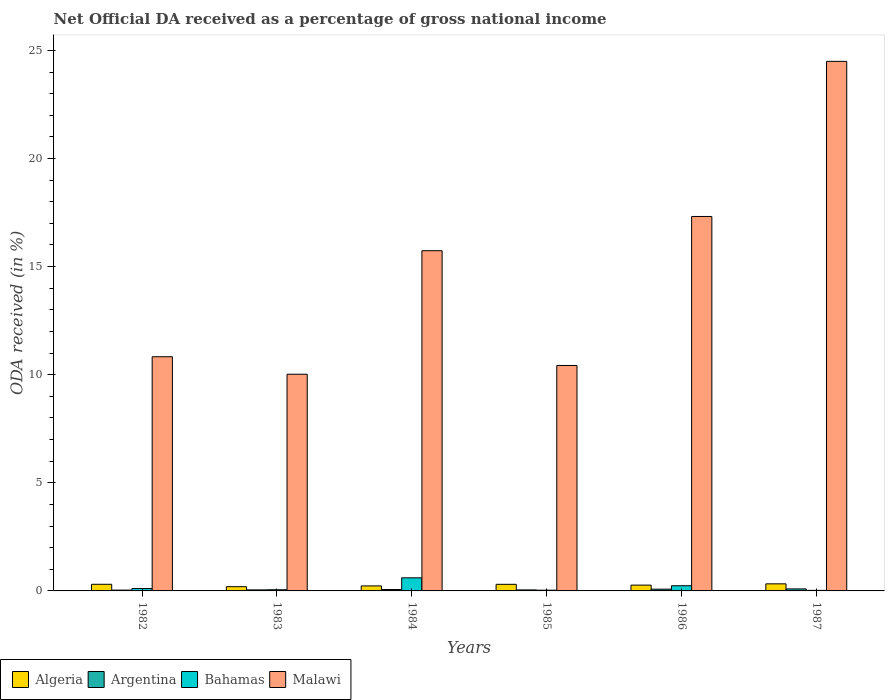How many groups of bars are there?
Offer a terse response. 6. Are the number of bars per tick equal to the number of legend labels?
Make the answer very short. Yes. Are the number of bars on each tick of the X-axis equal?
Offer a terse response. Yes. In how many cases, is the number of bars for a given year not equal to the number of legend labels?
Offer a very short reply. 0. What is the net official DA received in Bahamas in 1982?
Offer a very short reply. 0.11. Across all years, what is the maximum net official DA received in Malawi?
Provide a succinct answer. 24.49. Across all years, what is the minimum net official DA received in Algeria?
Keep it short and to the point. 0.2. In which year was the net official DA received in Argentina minimum?
Your response must be concise. 1982. What is the total net official DA received in Algeria in the graph?
Offer a very short reply. 1.64. What is the difference between the net official DA received in Bahamas in 1984 and that in 1987?
Keep it short and to the point. 0.58. What is the difference between the net official DA received in Bahamas in 1987 and the net official DA received in Algeria in 1984?
Ensure brevity in your answer.  -0.21. What is the average net official DA received in Argentina per year?
Offer a terse response. 0.06. In the year 1983, what is the difference between the net official DA received in Argentina and net official DA received in Malawi?
Give a very brief answer. -9.97. What is the ratio of the net official DA received in Argentina in 1986 to that in 1987?
Offer a terse response. 0.86. Is the net official DA received in Malawi in 1986 less than that in 1987?
Your response must be concise. Yes. Is the difference between the net official DA received in Argentina in 1983 and 1987 greater than the difference between the net official DA received in Malawi in 1983 and 1987?
Offer a terse response. Yes. What is the difference between the highest and the second highest net official DA received in Malawi?
Your answer should be compact. 7.18. What is the difference between the highest and the lowest net official DA received in Malawi?
Ensure brevity in your answer.  14.47. Is it the case that in every year, the sum of the net official DA received in Malawi and net official DA received in Bahamas is greater than the sum of net official DA received in Algeria and net official DA received in Argentina?
Offer a very short reply. No. Is it the case that in every year, the sum of the net official DA received in Malawi and net official DA received in Argentina is greater than the net official DA received in Bahamas?
Your response must be concise. Yes. How many bars are there?
Provide a succinct answer. 24. How many years are there in the graph?
Offer a terse response. 6. Are the values on the major ticks of Y-axis written in scientific E-notation?
Ensure brevity in your answer.  No. Does the graph contain grids?
Provide a succinct answer. No. Where does the legend appear in the graph?
Your answer should be very brief. Bottom left. How are the legend labels stacked?
Your response must be concise. Horizontal. What is the title of the graph?
Give a very brief answer. Net Official DA received as a percentage of gross national income. What is the label or title of the X-axis?
Provide a succinct answer. Years. What is the label or title of the Y-axis?
Your answer should be compact. ODA received (in %). What is the ODA received (in %) of Algeria in 1982?
Provide a succinct answer. 0.31. What is the ODA received (in %) in Argentina in 1982?
Make the answer very short. 0.04. What is the ODA received (in %) in Bahamas in 1982?
Give a very brief answer. 0.11. What is the ODA received (in %) of Malawi in 1982?
Offer a terse response. 10.83. What is the ODA received (in %) of Algeria in 1983?
Give a very brief answer. 0.2. What is the ODA received (in %) in Argentina in 1983?
Make the answer very short. 0.05. What is the ODA received (in %) in Bahamas in 1983?
Ensure brevity in your answer.  0.05. What is the ODA received (in %) in Malawi in 1983?
Ensure brevity in your answer.  10.02. What is the ODA received (in %) in Algeria in 1984?
Your answer should be very brief. 0.23. What is the ODA received (in %) in Argentina in 1984?
Provide a succinct answer. 0.06. What is the ODA received (in %) of Bahamas in 1984?
Offer a very short reply. 0.61. What is the ODA received (in %) in Malawi in 1984?
Provide a succinct answer. 15.74. What is the ODA received (in %) of Algeria in 1985?
Keep it short and to the point. 0.31. What is the ODA received (in %) in Argentina in 1985?
Your response must be concise. 0.05. What is the ODA received (in %) in Bahamas in 1985?
Make the answer very short. 0.03. What is the ODA received (in %) of Malawi in 1985?
Give a very brief answer. 10.43. What is the ODA received (in %) in Algeria in 1986?
Make the answer very short. 0.27. What is the ODA received (in %) in Argentina in 1986?
Offer a terse response. 0.08. What is the ODA received (in %) of Bahamas in 1986?
Provide a short and direct response. 0.24. What is the ODA received (in %) of Malawi in 1986?
Ensure brevity in your answer.  17.32. What is the ODA received (in %) in Algeria in 1987?
Give a very brief answer. 0.33. What is the ODA received (in %) of Argentina in 1987?
Keep it short and to the point. 0.09. What is the ODA received (in %) in Bahamas in 1987?
Give a very brief answer. 0.03. What is the ODA received (in %) in Malawi in 1987?
Offer a very short reply. 24.49. Across all years, what is the maximum ODA received (in %) of Algeria?
Your response must be concise. 0.33. Across all years, what is the maximum ODA received (in %) of Argentina?
Make the answer very short. 0.09. Across all years, what is the maximum ODA received (in %) in Bahamas?
Your answer should be very brief. 0.61. Across all years, what is the maximum ODA received (in %) of Malawi?
Offer a terse response. 24.49. Across all years, what is the minimum ODA received (in %) of Algeria?
Your response must be concise. 0.2. Across all years, what is the minimum ODA received (in %) in Argentina?
Make the answer very short. 0.04. Across all years, what is the minimum ODA received (in %) in Bahamas?
Your answer should be compact. 0.03. Across all years, what is the minimum ODA received (in %) in Malawi?
Keep it short and to the point. 10.02. What is the total ODA received (in %) of Algeria in the graph?
Ensure brevity in your answer.  1.64. What is the total ODA received (in %) in Argentina in the graph?
Keep it short and to the point. 0.37. What is the total ODA received (in %) in Bahamas in the graph?
Provide a short and direct response. 1.07. What is the total ODA received (in %) of Malawi in the graph?
Make the answer very short. 88.83. What is the difference between the ODA received (in %) of Algeria in 1982 and that in 1983?
Provide a short and direct response. 0.11. What is the difference between the ODA received (in %) of Argentina in 1982 and that in 1983?
Your answer should be compact. -0.01. What is the difference between the ODA received (in %) in Bahamas in 1982 and that in 1983?
Offer a very short reply. 0.06. What is the difference between the ODA received (in %) in Malawi in 1982 and that in 1983?
Offer a very short reply. 0.81. What is the difference between the ODA received (in %) in Algeria in 1982 and that in 1984?
Give a very brief answer. 0.08. What is the difference between the ODA received (in %) in Argentina in 1982 and that in 1984?
Give a very brief answer. -0.03. What is the difference between the ODA received (in %) of Bahamas in 1982 and that in 1984?
Your answer should be compact. -0.49. What is the difference between the ODA received (in %) of Malawi in 1982 and that in 1984?
Give a very brief answer. -4.9. What is the difference between the ODA received (in %) in Algeria in 1982 and that in 1985?
Give a very brief answer. 0. What is the difference between the ODA received (in %) of Argentina in 1982 and that in 1985?
Give a very brief answer. -0.01. What is the difference between the ODA received (in %) in Bahamas in 1982 and that in 1985?
Your response must be concise. 0.08. What is the difference between the ODA received (in %) of Malawi in 1982 and that in 1985?
Keep it short and to the point. 0.4. What is the difference between the ODA received (in %) in Algeria in 1982 and that in 1986?
Your answer should be very brief. 0.04. What is the difference between the ODA received (in %) in Argentina in 1982 and that in 1986?
Keep it short and to the point. -0.04. What is the difference between the ODA received (in %) in Bahamas in 1982 and that in 1986?
Provide a succinct answer. -0.13. What is the difference between the ODA received (in %) of Malawi in 1982 and that in 1986?
Provide a short and direct response. -6.49. What is the difference between the ODA received (in %) in Algeria in 1982 and that in 1987?
Give a very brief answer. -0.02. What is the difference between the ODA received (in %) of Argentina in 1982 and that in 1987?
Offer a terse response. -0.06. What is the difference between the ODA received (in %) in Bahamas in 1982 and that in 1987?
Your answer should be very brief. 0.09. What is the difference between the ODA received (in %) in Malawi in 1982 and that in 1987?
Keep it short and to the point. -13.66. What is the difference between the ODA received (in %) of Algeria in 1983 and that in 1984?
Keep it short and to the point. -0.04. What is the difference between the ODA received (in %) in Argentina in 1983 and that in 1984?
Your answer should be very brief. -0.02. What is the difference between the ODA received (in %) in Bahamas in 1983 and that in 1984?
Your answer should be compact. -0.55. What is the difference between the ODA received (in %) of Malawi in 1983 and that in 1984?
Offer a terse response. -5.71. What is the difference between the ODA received (in %) in Algeria in 1983 and that in 1985?
Offer a very short reply. -0.11. What is the difference between the ODA received (in %) of Argentina in 1983 and that in 1985?
Ensure brevity in your answer.  0. What is the difference between the ODA received (in %) in Bahamas in 1983 and that in 1985?
Provide a short and direct response. 0.02. What is the difference between the ODA received (in %) of Malawi in 1983 and that in 1985?
Give a very brief answer. -0.41. What is the difference between the ODA received (in %) in Algeria in 1983 and that in 1986?
Give a very brief answer. -0.07. What is the difference between the ODA received (in %) of Argentina in 1983 and that in 1986?
Make the answer very short. -0.03. What is the difference between the ODA received (in %) in Bahamas in 1983 and that in 1986?
Your answer should be compact. -0.19. What is the difference between the ODA received (in %) of Malawi in 1983 and that in 1986?
Ensure brevity in your answer.  -7.3. What is the difference between the ODA received (in %) in Algeria in 1983 and that in 1987?
Your response must be concise. -0.13. What is the difference between the ODA received (in %) in Argentina in 1983 and that in 1987?
Provide a succinct answer. -0.05. What is the difference between the ODA received (in %) in Bahamas in 1983 and that in 1987?
Offer a very short reply. 0.03. What is the difference between the ODA received (in %) in Malawi in 1983 and that in 1987?
Keep it short and to the point. -14.47. What is the difference between the ODA received (in %) in Algeria in 1984 and that in 1985?
Offer a very short reply. -0.07. What is the difference between the ODA received (in %) in Argentina in 1984 and that in 1985?
Your answer should be very brief. 0.02. What is the difference between the ODA received (in %) in Bahamas in 1984 and that in 1985?
Your answer should be compact. 0.57. What is the difference between the ODA received (in %) of Malawi in 1984 and that in 1985?
Provide a succinct answer. 5.31. What is the difference between the ODA received (in %) of Algeria in 1984 and that in 1986?
Offer a very short reply. -0.04. What is the difference between the ODA received (in %) in Argentina in 1984 and that in 1986?
Your answer should be very brief. -0.02. What is the difference between the ODA received (in %) in Bahamas in 1984 and that in 1986?
Make the answer very short. 0.37. What is the difference between the ODA received (in %) of Malawi in 1984 and that in 1986?
Ensure brevity in your answer.  -1.58. What is the difference between the ODA received (in %) in Algeria in 1984 and that in 1987?
Keep it short and to the point. -0.1. What is the difference between the ODA received (in %) of Argentina in 1984 and that in 1987?
Your answer should be very brief. -0.03. What is the difference between the ODA received (in %) in Bahamas in 1984 and that in 1987?
Offer a very short reply. 0.58. What is the difference between the ODA received (in %) in Malawi in 1984 and that in 1987?
Keep it short and to the point. -8.76. What is the difference between the ODA received (in %) of Algeria in 1985 and that in 1986?
Make the answer very short. 0.04. What is the difference between the ODA received (in %) in Argentina in 1985 and that in 1986?
Make the answer very short. -0.03. What is the difference between the ODA received (in %) of Bahamas in 1985 and that in 1986?
Your response must be concise. -0.21. What is the difference between the ODA received (in %) in Malawi in 1985 and that in 1986?
Your answer should be compact. -6.89. What is the difference between the ODA received (in %) of Algeria in 1985 and that in 1987?
Offer a terse response. -0.02. What is the difference between the ODA received (in %) in Argentina in 1985 and that in 1987?
Provide a succinct answer. -0.05. What is the difference between the ODA received (in %) in Bahamas in 1985 and that in 1987?
Your answer should be compact. 0.01. What is the difference between the ODA received (in %) in Malawi in 1985 and that in 1987?
Your answer should be very brief. -14.07. What is the difference between the ODA received (in %) of Algeria in 1986 and that in 1987?
Ensure brevity in your answer.  -0.06. What is the difference between the ODA received (in %) in Argentina in 1986 and that in 1987?
Give a very brief answer. -0.01. What is the difference between the ODA received (in %) of Bahamas in 1986 and that in 1987?
Your answer should be very brief. 0.21. What is the difference between the ODA received (in %) in Malawi in 1986 and that in 1987?
Provide a succinct answer. -7.18. What is the difference between the ODA received (in %) of Algeria in 1982 and the ODA received (in %) of Argentina in 1983?
Offer a very short reply. 0.26. What is the difference between the ODA received (in %) of Algeria in 1982 and the ODA received (in %) of Bahamas in 1983?
Keep it short and to the point. 0.25. What is the difference between the ODA received (in %) in Algeria in 1982 and the ODA received (in %) in Malawi in 1983?
Provide a short and direct response. -9.72. What is the difference between the ODA received (in %) of Argentina in 1982 and the ODA received (in %) of Bahamas in 1983?
Offer a terse response. -0.02. What is the difference between the ODA received (in %) of Argentina in 1982 and the ODA received (in %) of Malawi in 1983?
Your answer should be very brief. -9.98. What is the difference between the ODA received (in %) in Bahamas in 1982 and the ODA received (in %) in Malawi in 1983?
Offer a very short reply. -9.91. What is the difference between the ODA received (in %) of Algeria in 1982 and the ODA received (in %) of Argentina in 1984?
Keep it short and to the point. 0.24. What is the difference between the ODA received (in %) in Algeria in 1982 and the ODA received (in %) in Bahamas in 1984?
Provide a short and direct response. -0.3. What is the difference between the ODA received (in %) of Algeria in 1982 and the ODA received (in %) of Malawi in 1984?
Your response must be concise. -15.43. What is the difference between the ODA received (in %) in Argentina in 1982 and the ODA received (in %) in Bahamas in 1984?
Provide a succinct answer. -0.57. What is the difference between the ODA received (in %) of Argentina in 1982 and the ODA received (in %) of Malawi in 1984?
Offer a terse response. -15.7. What is the difference between the ODA received (in %) in Bahamas in 1982 and the ODA received (in %) in Malawi in 1984?
Provide a short and direct response. -15.63. What is the difference between the ODA received (in %) of Algeria in 1982 and the ODA received (in %) of Argentina in 1985?
Your answer should be very brief. 0.26. What is the difference between the ODA received (in %) of Algeria in 1982 and the ODA received (in %) of Bahamas in 1985?
Offer a very short reply. 0.27. What is the difference between the ODA received (in %) in Algeria in 1982 and the ODA received (in %) in Malawi in 1985?
Your answer should be compact. -10.12. What is the difference between the ODA received (in %) of Argentina in 1982 and the ODA received (in %) of Bahamas in 1985?
Your answer should be compact. 0. What is the difference between the ODA received (in %) of Argentina in 1982 and the ODA received (in %) of Malawi in 1985?
Your response must be concise. -10.39. What is the difference between the ODA received (in %) of Bahamas in 1982 and the ODA received (in %) of Malawi in 1985?
Provide a succinct answer. -10.32. What is the difference between the ODA received (in %) in Algeria in 1982 and the ODA received (in %) in Argentina in 1986?
Give a very brief answer. 0.23. What is the difference between the ODA received (in %) in Algeria in 1982 and the ODA received (in %) in Bahamas in 1986?
Your answer should be compact. 0.07. What is the difference between the ODA received (in %) in Algeria in 1982 and the ODA received (in %) in Malawi in 1986?
Make the answer very short. -17.01. What is the difference between the ODA received (in %) of Argentina in 1982 and the ODA received (in %) of Bahamas in 1986?
Provide a succinct answer. -0.2. What is the difference between the ODA received (in %) in Argentina in 1982 and the ODA received (in %) in Malawi in 1986?
Your response must be concise. -17.28. What is the difference between the ODA received (in %) in Bahamas in 1982 and the ODA received (in %) in Malawi in 1986?
Offer a very short reply. -17.21. What is the difference between the ODA received (in %) of Algeria in 1982 and the ODA received (in %) of Argentina in 1987?
Provide a succinct answer. 0.21. What is the difference between the ODA received (in %) of Algeria in 1982 and the ODA received (in %) of Bahamas in 1987?
Offer a terse response. 0.28. What is the difference between the ODA received (in %) in Algeria in 1982 and the ODA received (in %) in Malawi in 1987?
Your answer should be compact. -24.19. What is the difference between the ODA received (in %) in Argentina in 1982 and the ODA received (in %) in Bahamas in 1987?
Offer a very short reply. 0.01. What is the difference between the ODA received (in %) in Argentina in 1982 and the ODA received (in %) in Malawi in 1987?
Offer a very short reply. -24.46. What is the difference between the ODA received (in %) in Bahamas in 1982 and the ODA received (in %) in Malawi in 1987?
Keep it short and to the point. -24.38. What is the difference between the ODA received (in %) in Algeria in 1983 and the ODA received (in %) in Argentina in 1984?
Keep it short and to the point. 0.13. What is the difference between the ODA received (in %) of Algeria in 1983 and the ODA received (in %) of Bahamas in 1984?
Your answer should be compact. -0.41. What is the difference between the ODA received (in %) in Algeria in 1983 and the ODA received (in %) in Malawi in 1984?
Keep it short and to the point. -15.54. What is the difference between the ODA received (in %) in Argentina in 1983 and the ODA received (in %) in Bahamas in 1984?
Ensure brevity in your answer.  -0.56. What is the difference between the ODA received (in %) in Argentina in 1983 and the ODA received (in %) in Malawi in 1984?
Provide a succinct answer. -15.69. What is the difference between the ODA received (in %) in Bahamas in 1983 and the ODA received (in %) in Malawi in 1984?
Your response must be concise. -15.68. What is the difference between the ODA received (in %) in Algeria in 1983 and the ODA received (in %) in Argentina in 1985?
Provide a short and direct response. 0.15. What is the difference between the ODA received (in %) of Algeria in 1983 and the ODA received (in %) of Bahamas in 1985?
Make the answer very short. 0.16. What is the difference between the ODA received (in %) of Algeria in 1983 and the ODA received (in %) of Malawi in 1985?
Offer a terse response. -10.23. What is the difference between the ODA received (in %) in Argentina in 1983 and the ODA received (in %) in Bahamas in 1985?
Your answer should be compact. 0.01. What is the difference between the ODA received (in %) in Argentina in 1983 and the ODA received (in %) in Malawi in 1985?
Ensure brevity in your answer.  -10.38. What is the difference between the ODA received (in %) in Bahamas in 1983 and the ODA received (in %) in Malawi in 1985?
Your response must be concise. -10.37. What is the difference between the ODA received (in %) in Algeria in 1983 and the ODA received (in %) in Argentina in 1986?
Provide a short and direct response. 0.12. What is the difference between the ODA received (in %) of Algeria in 1983 and the ODA received (in %) of Bahamas in 1986?
Your answer should be compact. -0.04. What is the difference between the ODA received (in %) of Algeria in 1983 and the ODA received (in %) of Malawi in 1986?
Give a very brief answer. -17.12. What is the difference between the ODA received (in %) in Argentina in 1983 and the ODA received (in %) in Bahamas in 1986?
Your response must be concise. -0.19. What is the difference between the ODA received (in %) of Argentina in 1983 and the ODA received (in %) of Malawi in 1986?
Offer a terse response. -17.27. What is the difference between the ODA received (in %) in Bahamas in 1983 and the ODA received (in %) in Malawi in 1986?
Provide a succinct answer. -17.26. What is the difference between the ODA received (in %) in Algeria in 1983 and the ODA received (in %) in Argentina in 1987?
Provide a succinct answer. 0.1. What is the difference between the ODA received (in %) of Algeria in 1983 and the ODA received (in %) of Bahamas in 1987?
Offer a very short reply. 0.17. What is the difference between the ODA received (in %) of Algeria in 1983 and the ODA received (in %) of Malawi in 1987?
Your answer should be compact. -24.3. What is the difference between the ODA received (in %) of Argentina in 1983 and the ODA received (in %) of Bahamas in 1987?
Offer a terse response. 0.02. What is the difference between the ODA received (in %) in Argentina in 1983 and the ODA received (in %) in Malawi in 1987?
Your answer should be compact. -24.45. What is the difference between the ODA received (in %) in Bahamas in 1983 and the ODA received (in %) in Malawi in 1987?
Your response must be concise. -24.44. What is the difference between the ODA received (in %) of Algeria in 1984 and the ODA received (in %) of Argentina in 1985?
Offer a terse response. 0.18. What is the difference between the ODA received (in %) in Algeria in 1984 and the ODA received (in %) in Bahamas in 1985?
Give a very brief answer. 0.2. What is the difference between the ODA received (in %) in Algeria in 1984 and the ODA received (in %) in Malawi in 1985?
Provide a succinct answer. -10.2. What is the difference between the ODA received (in %) in Argentina in 1984 and the ODA received (in %) in Bahamas in 1985?
Ensure brevity in your answer.  0.03. What is the difference between the ODA received (in %) of Argentina in 1984 and the ODA received (in %) of Malawi in 1985?
Offer a terse response. -10.36. What is the difference between the ODA received (in %) in Bahamas in 1984 and the ODA received (in %) in Malawi in 1985?
Keep it short and to the point. -9.82. What is the difference between the ODA received (in %) in Algeria in 1984 and the ODA received (in %) in Argentina in 1986?
Offer a very short reply. 0.15. What is the difference between the ODA received (in %) in Algeria in 1984 and the ODA received (in %) in Bahamas in 1986?
Keep it short and to the point. -0.01. What is the difference between the ODA received (in %) of Algeria in 1984 and the ODA received (in %) of Malawi in 1986?
Ensure brevity in your answer.  -17.09. What is the difference between the ODA received (in %) of Argentina in 1984 and the ODA received (in %) of Bahamas in 1986?
Your response must be concise. -0.17. What is the difference between the ODA received (in %) in Argentina in 1984 and the ODA received (in %) in Malawi in 1986?
Keep it short and to the point. -17.25. What is the difference between the ODA received (in %) of Bahamas in 1984 and the ODA received (in %) of Malawi in 1986?
Your answer should be very brief. -16.71. What is the difference between the ODA received (in %) of Algeria in 1984 and the ODA received (in %) of Argentina in 1987?
Keep it short and to the point. 0.14. What is the difference between the ODA received (in %) of Algeria in 1984 and the ODA received (in %) of Bahamas in 1987?
Give a very brief answer. 0.21. What is the difference between the ODA received (in %) of Algeria in 1984 and the ODA received (in %) of Malawi in 1987?
Your answer should be very brief. -24.26. What is the difference between the ODA received (in %) of Argentina in 1984 and the ODA received (in %) of Bahamas in 1987?
Offer a terse response. 0.04. What is the difference between the ODA received (in %) in Argentina in 1984 and the ODA received (in %) in Malawi in 1987?
Offer a very short reply. -24.43. What is the difference between the ODA received (in %) of Bahamas in 1984 and the ODA received (in %) of Malawi in 1987?
Offer a terse response. -23.89. What is the difference between the ODA received (in %) of Algeria in 1985 and the ODA received (in %) of Argentina in 1986?
Your answer should be compact. 0.22. What is the difference between the ODA received (in %) of Algeria in 1985 and the ODA received (in %) of Bahamas in 1986?
Provide a succinct answer. 0.07. What is the difference between the ODA received (in %) in Algeria in 1985 and the ODA received (in %) in Malawi in 1986?
Offer a terse response. -17.01. What is the difference between the ODA received (in %) of Argentina in 1985 and the ODA received (in %) of Bahamas in 1986?
Give a very brief answer. -0.19. What is the difference between the ODA received (in %) in Argentina in 1985 and the ODA received (in %) in Malawi in 1986?
Your response must be concise. -17.27. What is the difference between the ODA received (in %) in Bahamas in 1985 and the ODA received (in %) in Malawi in 1986?
Keep it short and to the point. -17.28. What is the difference between the ODA received (in %) in Algeria in 1985 and the ODA received (in %) in Argentina in 1987?
Ensure brevity in your answer.  0.21. What is the difference between the ODA received (in %) in Algeria in 1985 and the ODA received (in %) in Bahamas in 1987?
Keep it short and to the point. 0.28. What is the difference between the ODA received (in %) of Algeria in 1985 and the ODA received (in %) of Malawi in 1987?
Offer a terse response. -24.19. What is the difference between the ODA received (in %) of Argentina in 1985 and the ODA received (in %) of Bahamas in 1987?
Provide a succinct answer. 0.02. What is the difference between the ODA received (in %) of Argentina in 1985 and the ODA received (in %) of Malawi in 1987?
Make the answer very short. -24.45. What is the difference between the ODA received (in %) in Bahamas in 1985 and the ODA received (in %) in Malawi in 1987?
Give a very brief answer. -24.46. What is the difference between the ODA received (in %) in Algeria in 1986 and the ODA received (in %) in Argentina in 1987?
Provide a succinct answer. 0.17. What is the difference between the ODA received (in %) of Algeria in 1986 and the ODA received (in %) of Bahamas in 1987?
Keep it short and to the point. 0.24. What is the difference between the ODA received (in %) in Algeria in 1986 and the ODA received (in %) in Malawi in 1987?
Give a very brief answer. -24.23. What is the difference between the ODA received (in %) of Argentina in 1986 and the ODA received (in %) of Bahamas in 1987?
Provide a succinct answer. 0.06. What is the difference between the ODA received (in %) of Argentina in 1986 and the ODA received (in %) of Malawi in 1987?
Your answer should be very brief. -24.41. What is the difference between the ODA received (in %) in Bahamas in 1986 and the ODA received (in %) in Malawi in 1987?
Provide a succinct answer. -24.25. What is the average ODA received (in %) of Algeria per year?
Give a very brief answer. 0.27. What is the average ODA received (in %) in Argentina per year?
Give a very brief answer. 0.06. What is the average ODA received (in %) of Bahamas per year?
Your response must be concise. 0.18. What is the average ODA received (in %) of Malawi per year?
Give a very brief answer. 14.8. In the year 1982, what is the difference between the ODA received (in %) in Algeria and ODA received (in %) in Argentina?
Give a very brief answer. 0.27. In the year 1982, what is the difference between the ODA received (in %) in Algeria and ODA received (in %) in Bahamas?
Offer a terse response. 0.2. In the year 1982, what is the difference between the ODA received (in %) of Algeria and ODA received (in %) of Malawi?
Make the answer very short. -10.52. In the year 1982, what is the difference between the ODA received (in %) in Argentina and ODA received (in %) in Bahamas?
Give a very brief answer. -0.07. In the year 1982, what is the difference between the ODA received (in %) of Argentina and ODA received (in %) of Malawi?
Give a very brief answer. -10.79. In the year 1982, what is the difference between the ODA received (in %) of Bahamas and ODA received (in %) of Malawi?
Offer a very short reply. -10.72. In the year 1983, what is the difference between the ODA received (in %) in Algeria and ODA received (in %) in Argentina?
Give a very brief answer. 0.15. In the year 1983, what is the difference between the ODA received (in %) of Algeria and ODA received (in %) of Bahamas?
Offer a very short reply. 0.14. In the year 1983, what is the difference between the ODA received (in %) of Algeria and ODA received (in %) of Malawi?
Provide a short and direct response. -9.83. In the year 1983, what is the difference between the ODA received (in %) of Argentina and ODA received (in %) of Bahamas?
Your answer should be compact. -0.01. In the year 1983, what is the difference between the ODA received (in %) of Argentina and ODA received (in %) of Malawi?
Your answer should be very brief. -9.97. In the year 1983, what is the difference between the ODA received (in %) of Bahamas and ODA received (in %) of Malawi?
Your answer should be very brief. -9.97. In the year 1984, what is the difference between the ODA received (in %) in Algeria and ODA received (in %) in Argentina?
Keep it short and to the point. 0.17. In the year 1984, what is the difference between the ODA received (in %) of Algeria and ODA received (in %) of Bahamas?
Provide a short and direct response. -0.37. In the year 1984, what is the difference between the ODA received (in %) of Algeria and ODA received (in %) of Malawi?
Provide a succinct answer. -15.5. In the year 1984, what is the difference between the ODA received (in %) in Argentina and ODA received (in %) in Bahamas?
Make the answer very short. -0.54. In the year 1984, what is the difference between the ODA received (in %) in Argentina and ODA received (in %) in Malawi?
Provide a succinct answer. -15.67. In the year 1984, what is the difference between the ODA received (in %) in Bahamas and ODA received (in %) in Malawi?
Your answer should be compact. -15.13. In the year 1985, what is the difference between the ODA received (in %) in Algeria and ODA received (in %) in Argentina?
Give a very brief answer. 0.26. In the year 1985, what is the difference between the ODA received (in %) of Algeria and ODA received (in %) of Bahamas?
Your answer should be compact. 0.27. In the year 1985, what is the difference between the ODA received (in %) of Algeria and ODA received (in %) of Malawi?
Give a very brief answer. -10.12. In the year 1985, what is the difference between the ODA received (in %) in Argentina and ODA received (in %) in Bahamas?
Your answer should be compact. 0.01. In the year 1985, what is the difference between the ODA received (in %) in Argentina and ODA received (in %) in Malawi?
Make the answer very short. -10.38. In the year 1985, what is the difference between the ODA received (in %) of Bahamas and ODA received (in %) of Malawi?
Your response must be concise. -10.39. In the year 1986, what is the difference between the ODA received (in %) of Algeria and ODA received (in %) of Argentina?
Ensure brevity in your answer.  0.19. In the year 1986, what is the difference between the ODA received (in %) in Algeria and ODA received (in %) in Bahamas?
Offer a very short reply. 0.03. In the year 1986, what is the difference between the ODA received (in %) in Algeria and ODA received (in %) in Malawi?
Keep it short and to the point. -17.05. In the year 1986, what is the difference between the ODA received (in %) of Argentina and ODA received (in %) of Bahamas?
Keep it short and to the point. -0.16. In the year 1986, what is the difference between the ODA received (in %) of Argentina and ODA received (in %) of Malawi?
Make the answer very short. -17.24. In the year 1986, what is the difference between the ODA received (in %) of Bahamas and ODA received (in %) of Malawi?
Keep it short and to the point. -17.08. In the year 1987, what is the difference between the ODA received (in %) of Algeria and ODA received (in %) of Argentina?
Your response must be concise. 0.23. In the year 1987, what is the difference between the ODA received (in %) of Algeria and ODA received (in %) of Bahamas?
Your response must be concise. 0.3. In the year 1987, what is the difference between the ODA received (in %) in Algeria and ODA received (in %) in Malawi?
Your answer should be very brief. -24.17. In the year 1987, what is the difference between the ODA received (in %) of Argentina and ODA received (in %) of Bahamas?
Your response must be concise. 0.07. In the year 1987, what is the difference between the ODA received (in %) in Argentina and ODA received (in %) in Malawi?
Provide a short and direct response. -24.4. In the year 1987, what is the difference between the ODA received (in %) in Bahamas and ODA received (in %) in Malawi?
Your response must be concise. -24.47. What is the ratio of the ODA received (in %) in Algeria in 1982 to that in 1983?
Keep it short and to the point. 1.57. What is the ratio of the ODA received (in %) of Argentina in 1982 to that in 1983?
Provide a succinct answer. 0.78. What is the ratio of the ODA received (in %) of Bahamas in 1982 to that in 1983?
Your answer should be very brief. 2.05. What is the ratio of the ODA received (in %) of Malawi in 1982 to that in 1983?
Keep it short and to the point. 1.08. What is the ratio of the ODA received (in %) in Algeria in 1982 to that in 1984?
Ensure brevity in your answer.  1.32. What is the ratio of the ODA received (in %) in Argentina in 1982 to that in 1984?
Your answer should be compact. 0.58. What is the ratio of the ODA received (in %) of Bahamas in 1982 to that in 1984?
Your answer should be very brief. 0.18. What is the ratio of the ODA received (in %) of Malawi in 1982 to that in 1984?
Your answer should be very brief. 0.69. What is the ratio of the ODA received (in %) in Argentina in 1982 to that in 1985?
Provide a succinct answer. 0.8. What is the ratio of the ODA received (in %) in Bahamas in 1982 to that in 1985?
Offer a very short reply. 3.26. What is the ratio of the ODA received (in %) of Malawi in 1982 to that in 1985?
Make the answer very short. 1.04. What is the ratio of the ODA received (in %) of Algeria in 1982 to that in 1986?
Your answer should be very brief. 1.14. What is the ratio of the ODA received (in %) in Argentina in 1982 to that in 1986?
Your answer should be compact. 0.46. What is the ratio of the ODA received (in %) of Bahamas in 1982 to that in 1986?
Make the answer very short. 0.46. What is the ratio of the ODA received (in %) of Malawi in 1982 to that in 1986?
Offer a very short reply. 0.63. What is the ratio of the ODA received (in %) of Argentina in 1982 to that in 1987?
Your answer should be very brief. 0.4. What is the ratio of the ODA received (in %) in Bahamas in 1982 to that in 1987?
Your answer should be compact. 4.33. What is the ratio of the ODA received (in %) in Malawi in 1982 to that in 1987?
Provide a succinct answer. 0.44. What is the ratio of the ODA received (in %) of Algeria in 1983 to that in 1984?
Your answer should be very brief. 0.85. What is the ratio of the ODA received (in %) of Argentina in 1983 to that in 1984?
Your answer should be very brief. 0.74. What is the ratio of the ODA received (in %) in Bahamas in 1983 to that in 1984?
Offer a very short reply. 0.09. What is the ratio of the ODA received (in %) of Malawi in 1983 to that in 1984?
Provide a short and direct response. 0.64. What is the ratio of the ODA received (in %) of Algeria in 1983 to that in 1985?
Give a very brief answer. 0.64. What is the ratio of the ODA received (in %) of Argentina in 1983 to that in 1985?
Your answer should be compact. 1.03. What is the ratio of the ODA received (in %) in Bahamas in 1983 to that in 1985?
Offer a terse response. 1.59. What is the ratio of the ODA received (in %) of Malawi in 1983 to that in 1985?
Provide a succinct answer. 0.96. What is the ratio of the ODA received (in %) in Algeria in 1983 to that in 1986?
Make the answer very short. 0.73. What is the ratio of the ODA received (in %) in Argentina in 1983 to that in 1986?
Offer a terse response. 0.59. What is the ratio of the ODA received (in %) in Bahamas in 1983 to that in 1986?
Keep it short and to the point. 0.23. What is the ratio of the ODA received (in %) in Malawi in 1983 to that in 1986?
Your answer should be very brief. 0.58. What is the ratio of the ODA received (in %) in Algeria in 1983 to that in 1987?
Your answer should be very brief. 0.6. What is the ratio of the ODA received (in %) of Argentina in 1983 to that in 1987?
Keep it short and to the point. 0.51. What is the ratio of the ODA received (in %) in Bahamas in 1983 to that in 1987?
Your answer should be compact. 2.11. What is the ratio of the ODA received (in %) of Malawi in 1983 to that in 1987?
Keep it short and to the point. 0.41. What is the ratio of the ODA received (in %) in Algeria in 1984 to that in 1985?
Keep it short and to the point. 0.76. What is the ratio of the ODA received (in %) in Argentina in 1984 to that in 1985?
Ensure brevity in your answer.  1.39. What is the ratio of the ODA received (in %) of Bahamas in 1984 to that in 1985?
Your answer should be very brief. 17.86. What is the ratio of the ODA received (in %) of Malawi in 1984 to that in 1985?
Your answer should be very brief. 1.51. What is the ratio of the ODA received (in %) of Algeria in 1984 to that in 1986?
Offer a very short reply. 0.86. What is the ratio of the ODA received (in %) of Argentina in 1984 to that in 1986?
Ensure brevity in your answer.  0.8. What is the ratio of the ODA received (in %) in Bahamas in 1984 to that in 1986?
Ensure brevity in your answer.  2.53. What is the ratio of the ODA received (in %) in Malawi in 1984 to that in 1986?
Make the answer very short. 0.91. What is the ratio of the ODA received (in %) in Algeria in 1984 to that in 1987?
Keep it short and to the point. 0.71. What is the ratio of the ODA received (in %) in Argentina in 1984 to that in 1987?
Make the answer very short. 0.69. What is the ratio of the ODA received (in %) of Bahamas in 1984 to that in 1987?
Keep it short and to the point. 23.69. What is the ratio of the ODA received (in %) of Malawi in 1984 to that in 1987?
Give a very brief answer. 0.64. What is the ratio of the ODA received (in %) of Algeria in 1985 to that in 1986?
Your response must be concise. 1.14. What is the ratio of the ODA received (in %) of Argentina in 1985 to that in 1986?
Provide a succinct answer. 0.58. What is the ratio of the ODA received (in %) of Bahamas in 1985 to that in 1986?
Offer a terse response. 0.14. What is the ratio of the ODA received (in %) in Malawi in 1985 to that in 1986?
Keep it short and to the point. 0.6. What is the ratio of the ODA received (in %) of Algeria in 1985 to that in 1987?
Make the answer very short. 0.93. What is the ratio of the ODA received (in %) of Argentina in 1985 to that in 1987?
Keep it short and to the point. 0.5. What is the ratio of the ODA received (in %) of Bahamas in 1985 to that in 1987?
Your answer should be compact. 1.33. What is the ratio of the ODA received (in %) in Malawi in 1985 to that in 1987?
Provide a short and direct response. 0.43. What is the ratio of the ODA received (in %) in Algeria in 1986 to that in 1987?
Make the answer very short. 0.82. What is the ratio of the ODA received (in %) of Argentina in 1986 to that in 1987?
Make the answer very short. 0.86. What is the ratio of the ODA received (in %) of Bahamas in 1986 to that in 1987?
Make the answer very short. 9.36. What is the ratio of the ODA received (in %) of Malawi in 1986 to that in 1987?
Make the answer very short. 0.71. What is the difference between the highest and the second highest ODA received (in %) of Algeria?
Offer a very short reply. 0.02. What is the difference between the highest and the second highest ODA received (in %) in Argentina?
Provide a succinct answer. 0.01. What is the difference between the highest and the second highest ODA received (in %) of Bahamas?
Provide a succinct answer. 0.37. What is the difference between the highest and the second highest ODA received (in %) in Malawi?
Offer a terse response. 7.18. What is the difference between the highest and the lowest ODA received (in %) in Algeria?
Your answer should be compact. 0.13. What is the difference between the highest and the lowest ODA received (in %) of Argentina?
Ensure brevity in your answer.  0.06. What is the difference between the highest and the lowest ODA received (in %) of Bahamas?
Your answer should be compact. 0.58. What is the difference between the highest and the lowest ODA received (in %) in Malawi?
Make the answer very short. 14.47. 